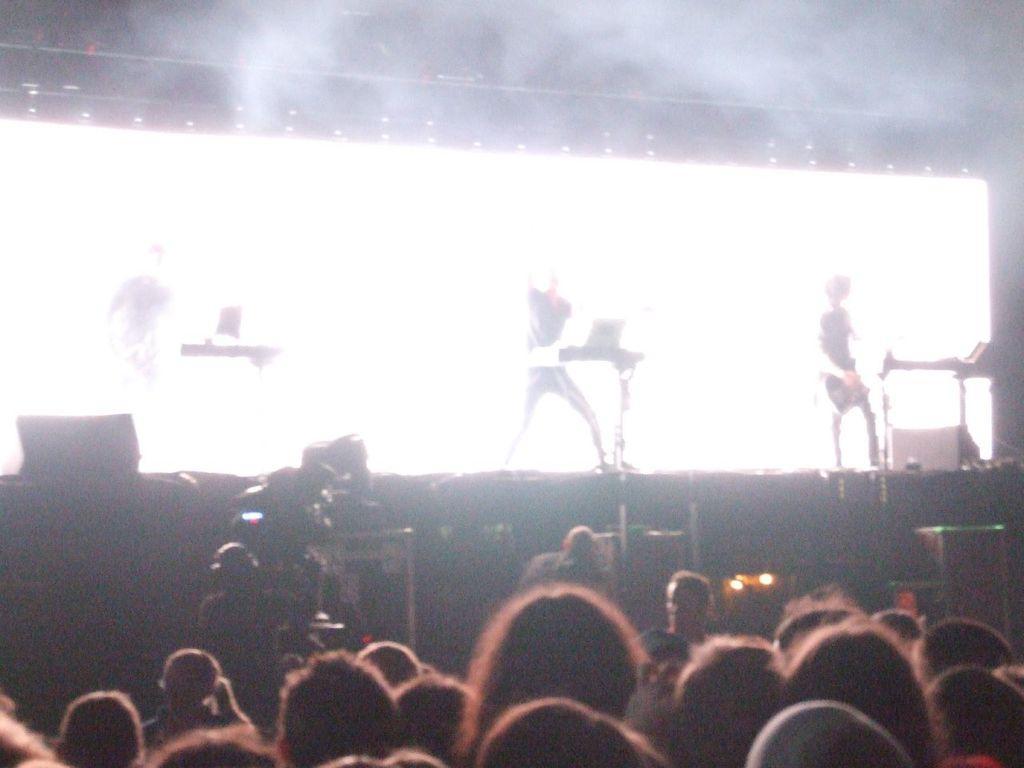In one or two sentences, can you explain what this image depicts? In this image in the front there are persons. In the background there are musicians performing on the stage and in the center there are cameras and on the top there are lights. 